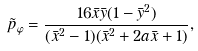<formula> <loc_0><loc_0><loc_500><loc_500>\tilde { p } _ { \varphi } = \frac { 1 6 \bar { x } \bar { y } ( 1 - \bar { y } ^ { 2 } ) } { ( \bar { x } ^ { 2 } - 1 ) ( \bar { x } ^ { 2 } + 2 a \bar { x } + 1 ) } ,</formula> 